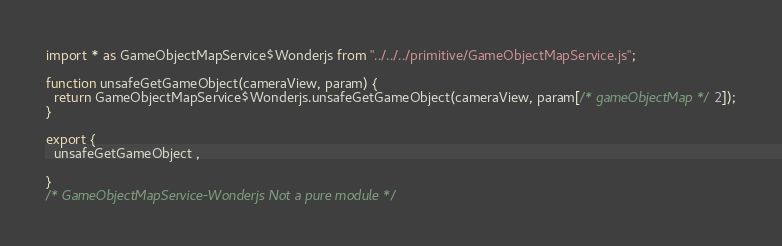Convert code to text. <code><loc_0><loc_0><loc_500><loc_500><_JavaScript_>

import * as GameObjectMapService$Wonderjs from "../../../primitive/GameObjectMapService.js";

function unsafeGetGameObject(cameraView, param) {
  return GameObjectMapService$Wonderjs.unsafeGetGameObject(cameraView, param[/* gameObjectMap */2]);
}

export {
  unsafeGetGameObject ,
  
}
/* GameObjectMapService-Wonderjs Not a pure module */
</code> 